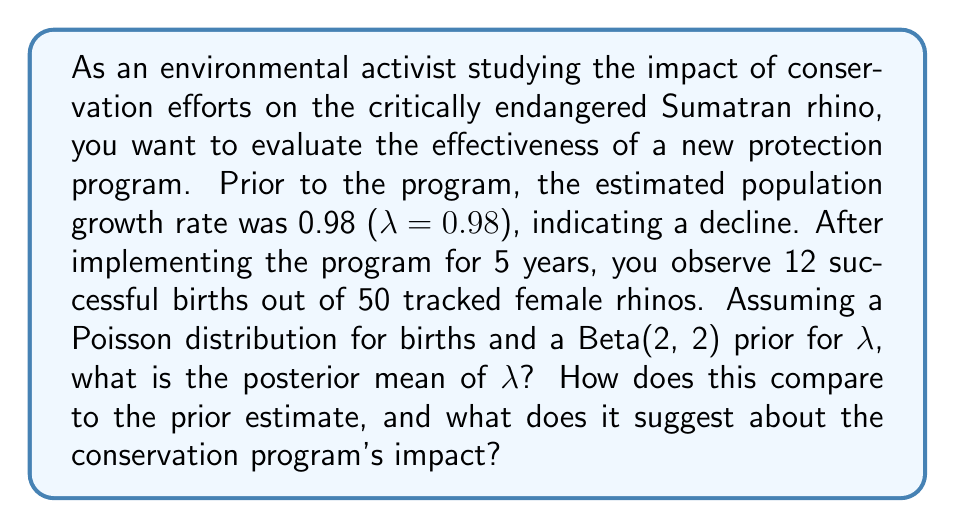Could you help me with this problem? To solve this problem, we'll use Bayesian inference with a Beta-Poisson model. The steps are as follows:

1) Prior distribution: We're given a Beta(2, 2) prior for λ. The prior mean is:
   $$E[λ] = \frac{α}{α + β} = \frac{2}{2 + 2} = 0.5$$

2) Likelihood: We observe 12 births from 50 rhinos over 5 years. The likelihood follows a Poisson distribution with mean 50 * 5 * λ = 250λ.

3) Posterior distribution: For a Beta prior and Poisson likelihood, the posterior is also a Beta distribution. The parameters of the posterior Beta are:
   $$α_{post} = α_{prior} + x$$
   $$β_{post} = β_{prior} + n$$
   where x is the number of observed events (births) and n is the total exposure (rhino-years).

   So, $$α_{post} = 2 + 12 = 14$$
   $$β_{post} = 2 + 250 = 252$$

4) Posterior mean:
   $$E[λ|data] = \frac{α_{post}}{α_{post} + β_{post}} = \frac{14}{14 + 252} = \frac{14}{266} ≈ 0.0526$$

5) Comparing to the prior estimate:
   The prior estimate of λ was 0.98, indicating population decline.
   The posterior mean of 0.0526 represents the estimated annual birth rate per rhino.
   To compare with the prior, we need to convert this to a population growth rate:
   $$λ_{growth} = 1 + (birth rate - death rate)$$
   Assuming the death rate hasn't changed significantly, the new growth rate would be approximately:
   $$λ_{growth} ≈ 1 + (0.0526 - 0.02) = 1.0326$$

This suggests that the population is now growing at about 3.26% per year, compared to the previous decline of 2% per year (λ = 0.98).
Answer: The posterior mean of λ (annual birth rate per rhino) is approximately 0.0526. This corresponds to an estimated population growth rate of about 1.0326, suggesting that the conservation program has had a positive impact, potentially reversing the population decline and leading to modest growth. 